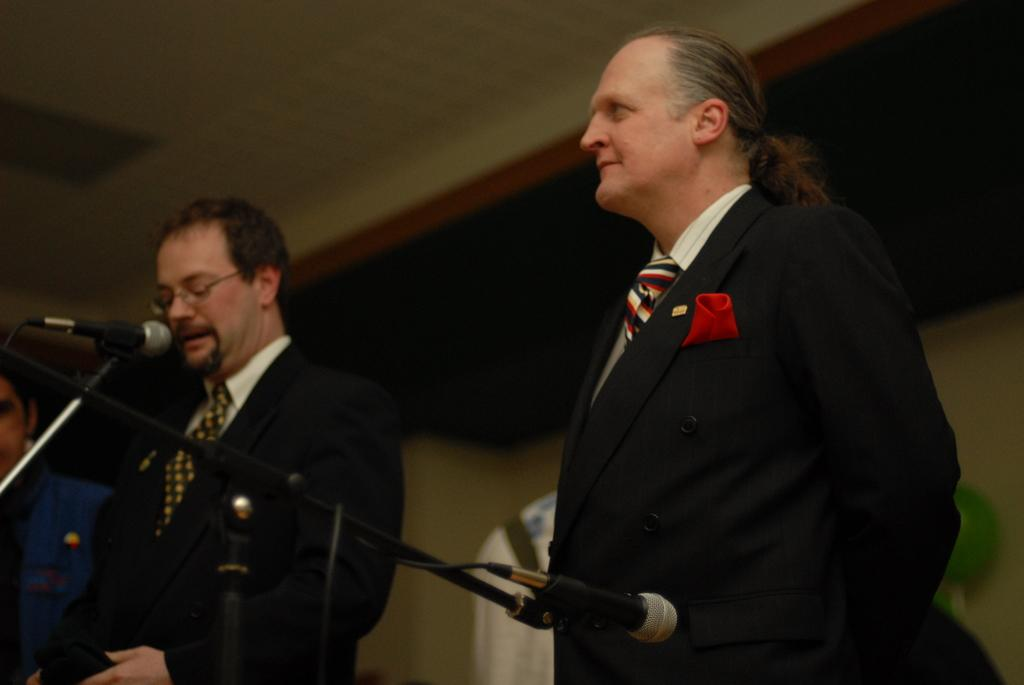What is happening in the room in the image? There are people standing in the room. What objects are in front of the people? There are two microphones in front of the people. What type of store can be seen in the background of the image? There is no store visible in the image; it only shows people standing in a room with microphones in front of them. 